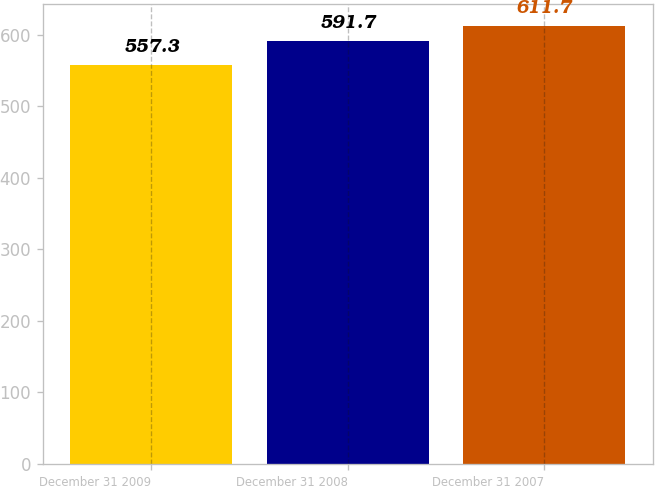<chart> <loc_0><loc_0><loc_500><loc_500><bar_chart><fcel>December 31 2009<fcel>December 31 2008<fcel>December 31 2007<nl><fcel>557.3<fcel>591.7<fcel>611.7<nl></chart> 